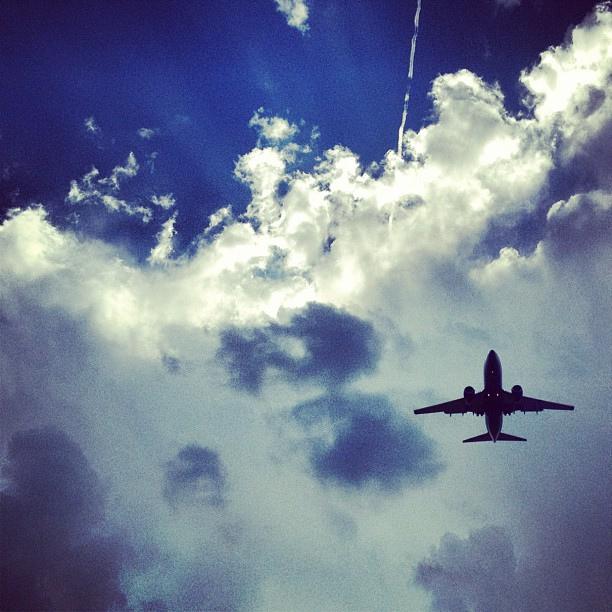What is white in the sky?
Answer briefly. Clouds. What kind of plane is this?
Quick response, please. Passenger. How many engines does the plane have?
Give a very brief answer. 2. Does the plane appear to be descending?
Quick response, please. No. Is the picture in color?
Quick response, please. Yes. 